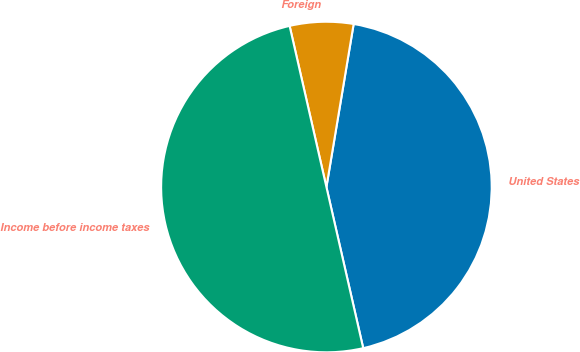Convert chart. <chart><loc_0><loc_0><loc_500><loc_500><pie_chart><fcel>United States<fcel>Foreign<fcel>Income before income taxes<nl><fcel>43.79%<fcel>6.21%<fcel>50.0%<nl></chart> 